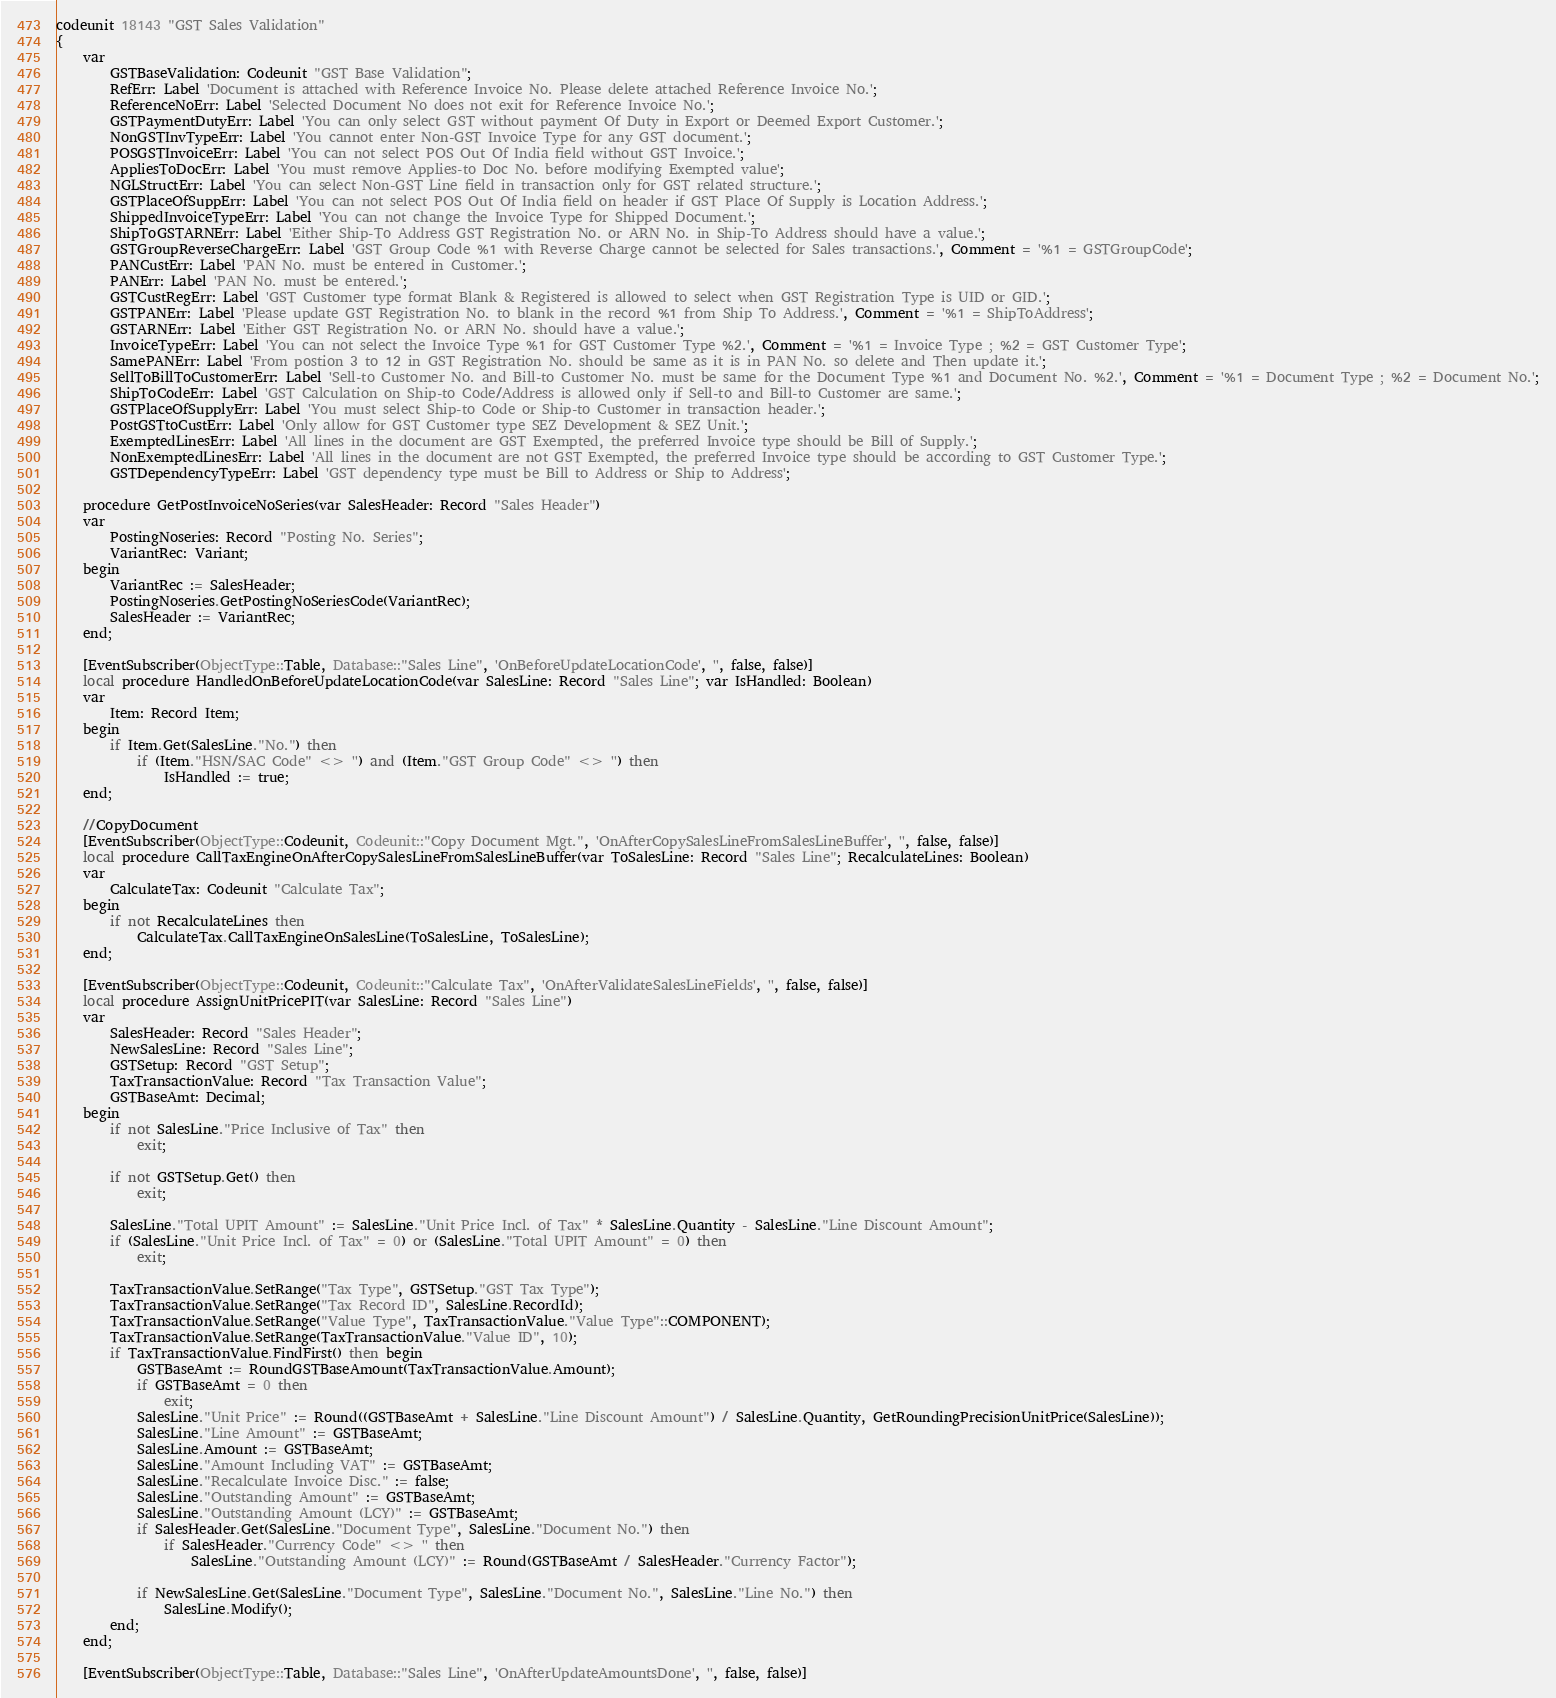<code> <loc_0><loc_0><loc_500><loc_500><_Perl_>codeunit 18143 "GST Sales Validation"
{
    var
        GSTBaseValidation: Codeunit "GST Base Validation";
        RefErr: Label 'Document is attached with Reference Invoice No. Please delete attached Reference Invoice No.';
        ReferenceNoErr: Label 'Selected Document No does not exit for Reference Invoice No.';
        GSTPaymentDutyErr: Label 'You can only select GST without payment Of Duty in Export or Deemed Export Customer.';
        NonGSTInvTypeErr: Label 'You cannot enter Non-GST Invoice Type for any GST document.';
        POSGSTInvoiceErr: Label 'You can not select POS Out Of India field without GST Invoice.';
        AppliesToDocErr: Label 'You must remove Applies-to Doc No. before modifying Exempted value';
        NGLStructErr: Label 'You can select Non-GST Line field in transaction only for GST related structure.';
        GSTPlaceOfSuppErr: Label 'You can not select POS Out Of India field on header if GST Place Of Supply is Location Address.';
        ShippedInvoiceTypeErr: Label 'You can not change the Invoice Type for Shipped Document.';
        ShipToGSTARNErr: Label 'Either Ship-To Address GST Registration No. or ARN No. in Ship-To Address should have a value.';
        GSTGroupReverseChargeErr: Label 'GST Group Code %1 with Reverse Charge cannot be selected for Sales transactions.', Comment = '%1 = GSTGroupCode';
        PANCustErr: Label 'PAN No. must be entered in Customer.';
        PANErr: Label 'PAN No. must be entered.';
        GSTCustRegErr: Label 'GST Customer type format Blank & Registered is allowed to select when GST Registration Type is UID or GID.';
        GSTPANErr: Label 'Please update GST Registration No. to blank in the record %1 from Ship To Address.', Comment = '%1 = ShipToAddress';
        GSTARNErr: Label 'Either GST Registration No. or ARN No. should have a value.';
        InvoiceTypeErr: Label 'You can not select the Invoice Type %1 for GST Customer Type %2.', Comment = '%1 = Invoice Type ; %2 = GST Customer Type';
        SamePANErr: Label 'From postion 3 to 12 in GST Registration No. should be same as it is in PAN No. so delete and Then update it.';
        SellToBillToCustomerErr: Label 'Sell-to Customer No. and Bill-to Customer No. must be same for the Document Type %1 and Document No. %2.', Comment = '%1 = Document Type ; %2 = Document No.';
        ShipToCodeErr: Label 'GST Calculation on Ship-to Code/Address is allowed only if Sell-to and Bill-to Customer are same.';
        GSTPlaceOfSupplyErr: Label 'You must select Ship-to Code or Ship-to Customer in transaction header.';
        PostGSTtoCustErr: Label 'Only allow for GST Customer type SEZ Development & SEZ Unit.';
        ExemptedLinesErr: Label 'All lines in the document are GST Exempted, the preferred Invoice type should be Bill of Supply.';
        NonExemptedLinesErr: Label 'All lines in the document are not GST Exempted, the preferred Invoice type should be according to GST Customer Type.';
        GSTDependencyTypeErr: Label 'GST dependency type must be Bill to Address or Ship to Address';

    procedure GetPostInvoiceNoSeries(var SalesHeader: Record "Sales Header")
    var
        PostingNoseries: Record "Posting No. Series";
        VariantRec: Variant;
    begin
        VariantRec := SalesHeader;
        PostingNoseries.GetPostingNoSeriesCode(VariantRec);
        SalesHeader := VariantRec;
    end;

    [EventSubscriber(ObjectType::Table, Database::"Sales Line", 'OnBeforeUpdateLocationCode', '', false, false)]
    local procedure HandledOnBeforeUpdateLocationCode(var SalesLine: Record "Sales Line"; var IsHandled: Boolean)
    var
        Item: Record Item;
    begin
        if Item.Get(SalesLine."No.") then
            if (Item."HSN/SAC Code" <> '') and (Item."GST Group Code" <> '') then
                IsHandled := true;
    end;

    //CopyDocument 
    [EventSubscriber(ObjectType::Codeunit, Codeunit::"Copy Document Mgt.", 'OnAfterCopySalesLineFromSalesLineBuffer', '', false, false)]
    local procedure CallTaxEngineOnAfterCopySalesLineFromSalesLineBuffer(var ToSalesLine: Record "Sales Line"; RecalculateLines: Boolean)
    var
        CalculateTax: Codeunit "Calculate Tax";
    begin
        if not RecalculateLines then
            CalculateTax.CallTaxEngineOnSalesLine(ToSalesLine, ToSalesLine);
    end;

    [EventSubscriber(ObjectType::Codeunit, Codeunit::"Calculate Tax", 'OnAfterValidateSalesLineFields', '', false, false)]
    local procedure AssignUnitPricePIT(var SalesLine: Record "Sales Line")
    var
        SalesHeader: Record "Sales Header";
        NewSalesLine: Record "Sales Line";
        GSTSetup: Record "GST Setup";
        TaxTransactionValue: Record "Tax Transaction Value";
        GSTBaseAmt: Decimal;
    begin
        if not SalesLine."Price Inclusive of Tax" then
            exit;

        if not GSTSetup.Get() then
            exit;

        SalesLine."Total UPIT Amount" := SalesLine."Unit Price Incl. of Tax" * SalesLine.Quantity - SalesLine."Line Discount Amount";
        if (SalesLine."Unit Price Incl. of Tax" = 0) or (SalesLine."Total UPIT Amount" = 0) then
            exit;

        TaxTransactionValue.SetRange("Tax Type", GSTSetup."GST Tax Type");
        TaxTransactionValue.SetRange("Tax Record ID", SalesLine.RecordId);
        TaxTransactionValue.SetRange("Value Type", TaxTransactionValue."Value Type"::COMPONENT);
        TaxTransactionValue.SetRange(TaxTransactionValue."Value ID", 10);
        if TaxTransactionValue.FindFirst() then begin
            GSTBaseAmt := RoundGSTBaseAmount(TaxTransactionValue.Amount);
            if GSTBaseAmt = 0 then
                exit;
            SalesLine."Unit Price" := Round((GSTBaseAmt + SalesLine."Line Discount Amount") / SalesLine.Quantity, GetRoundingPrecisionUnitPrice(SalesLine));
            SalesLine."Line Amount" := GSTBaseAmt;
            SalesLine.Amount := GSTBaseAmt;
            SalesLine."Amount Including VAT" := GSTBaseAmt;
            SalesLine."Recalculate Invoice Disc." := false;
            SalesLine."Outstanding Amount" := GSTBaseAmt;
            SalesLine."Outstanding Amount (LCY)" := GSTBaseAmt;
            if SalesHeader.Get(SalesLine."Document Type", SalesLine."Document No.") then
                if SalesHeader."Currency Code" <> '' then
                    SalesLine."Outstanding Amount (LCY)" := Round(GSTBaseAmt / SalesHeader."Currency Factor");

            if NewSalesLine.Get(SalesLine."Document Type", SalesLine."Document No.", SalesLine."Line No.") then
                SalesLine.Modify();
        end;
    end;

    [EventSubscriber(ObjectType::Table, Database::"Sales Line", 'OnAfterUpdateAmountsDone', '', false, false)]</code> 